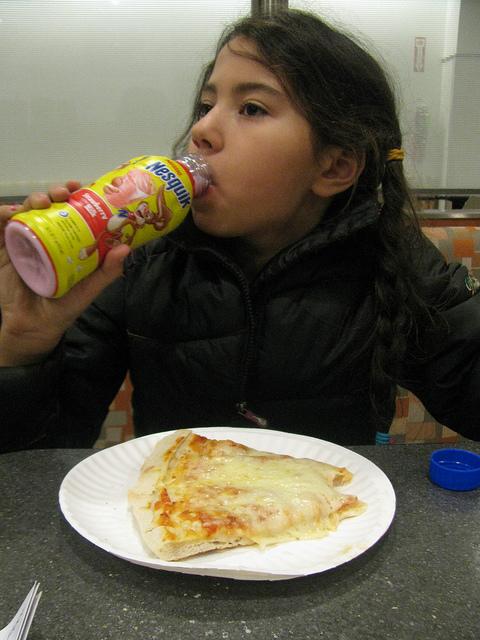What is on the plate?
Write a very short answer. Pizza. What is she drinking?
Quick response, please. Nesquik. Is she wearing a hat?
Quick response, please. No. 